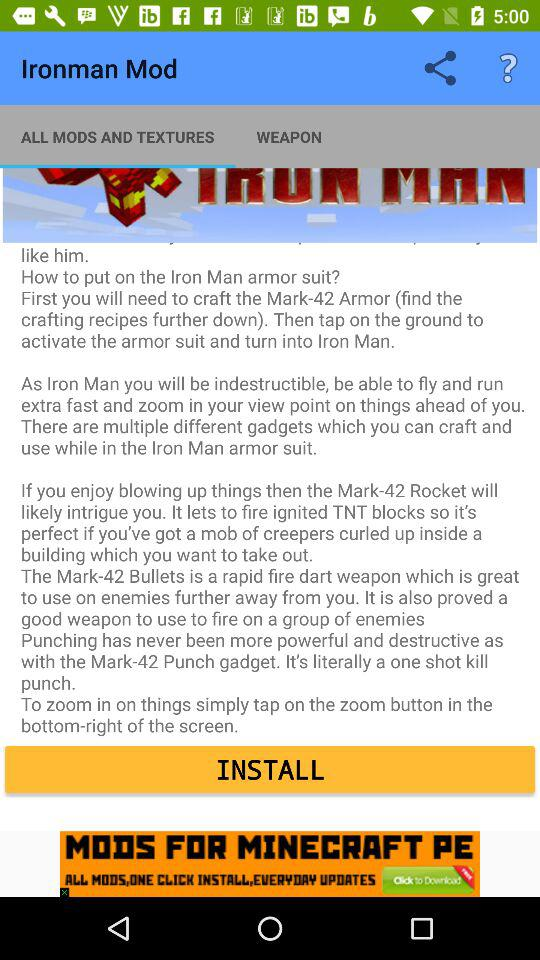Which tab is selected? The selected tab is "ALL MODS AND TEXTURES". 